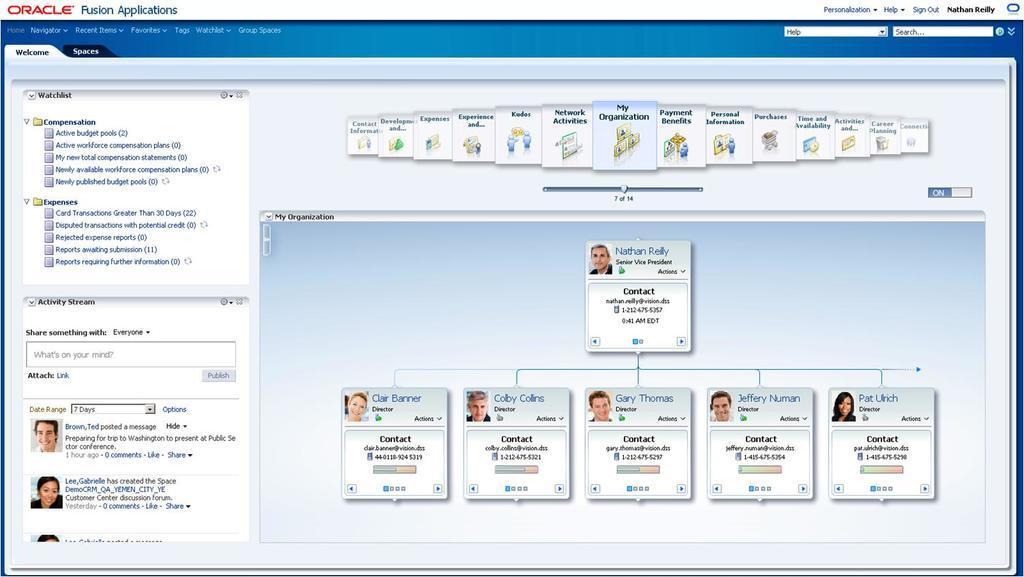How would you summarize this image in a sentence or two? This image consists of a web page with a few images of human and there is a text on it. 